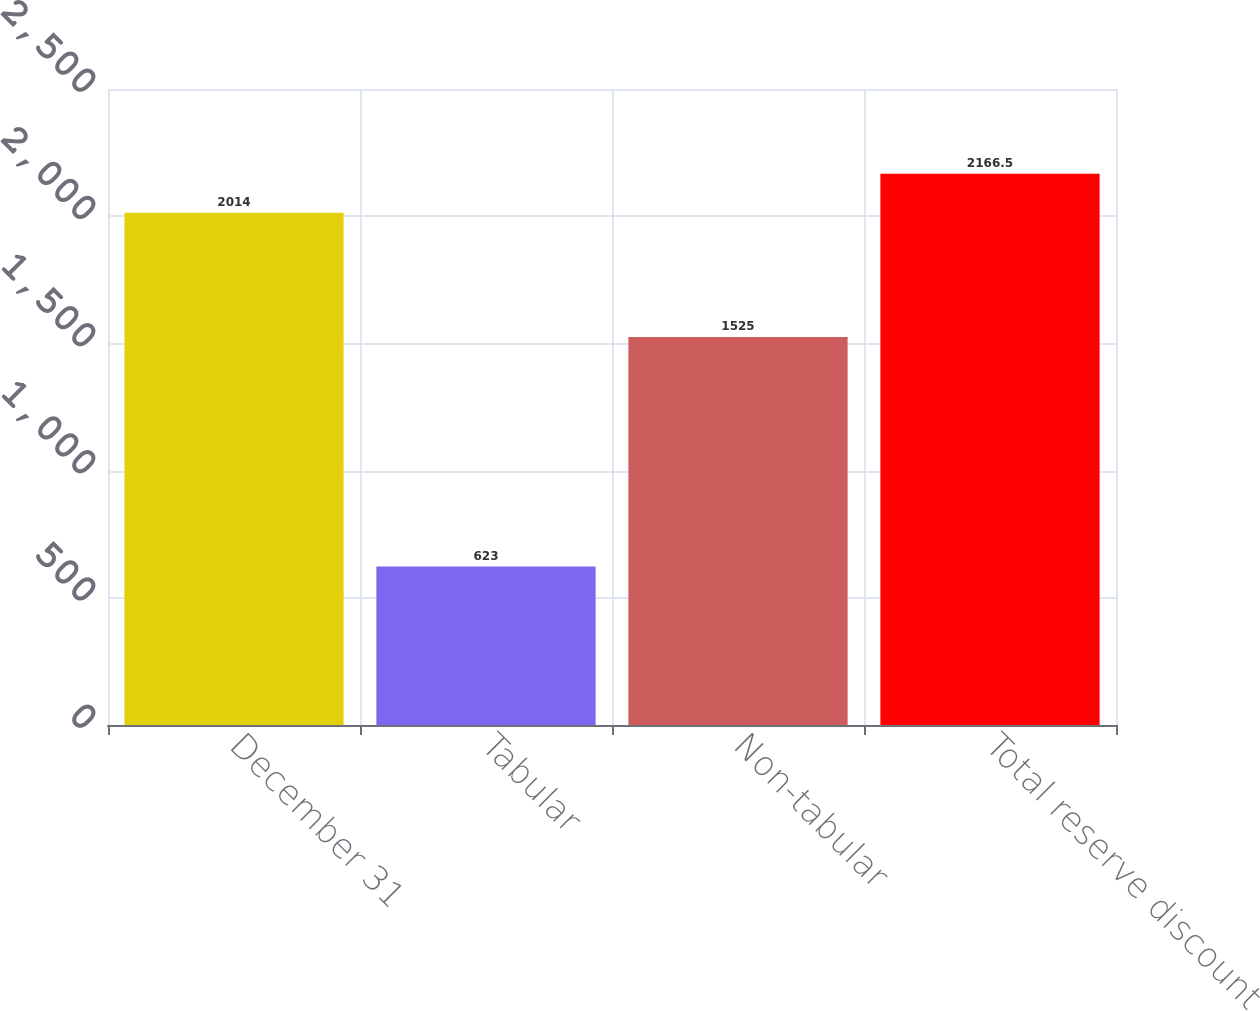<chart> <loc_0><loc_0><loc_500><loc_500><bar_chart><fcel>December 31<fcel>Tabular<fcel>Non-tabular<fcel>Total reserve discount<nl><fcel>2014<fcel>623<fcel>1525<fcel>2166.5<nl></chart> 